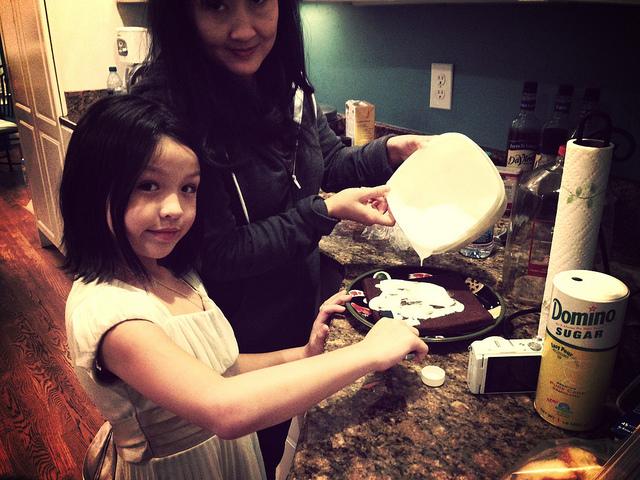What brand of sugar are they using?
Short answer required. Domino. What are they doing together?
Give a very brief answer. Cooking. Is the girl sewing?
Give a very brief answer. No. 